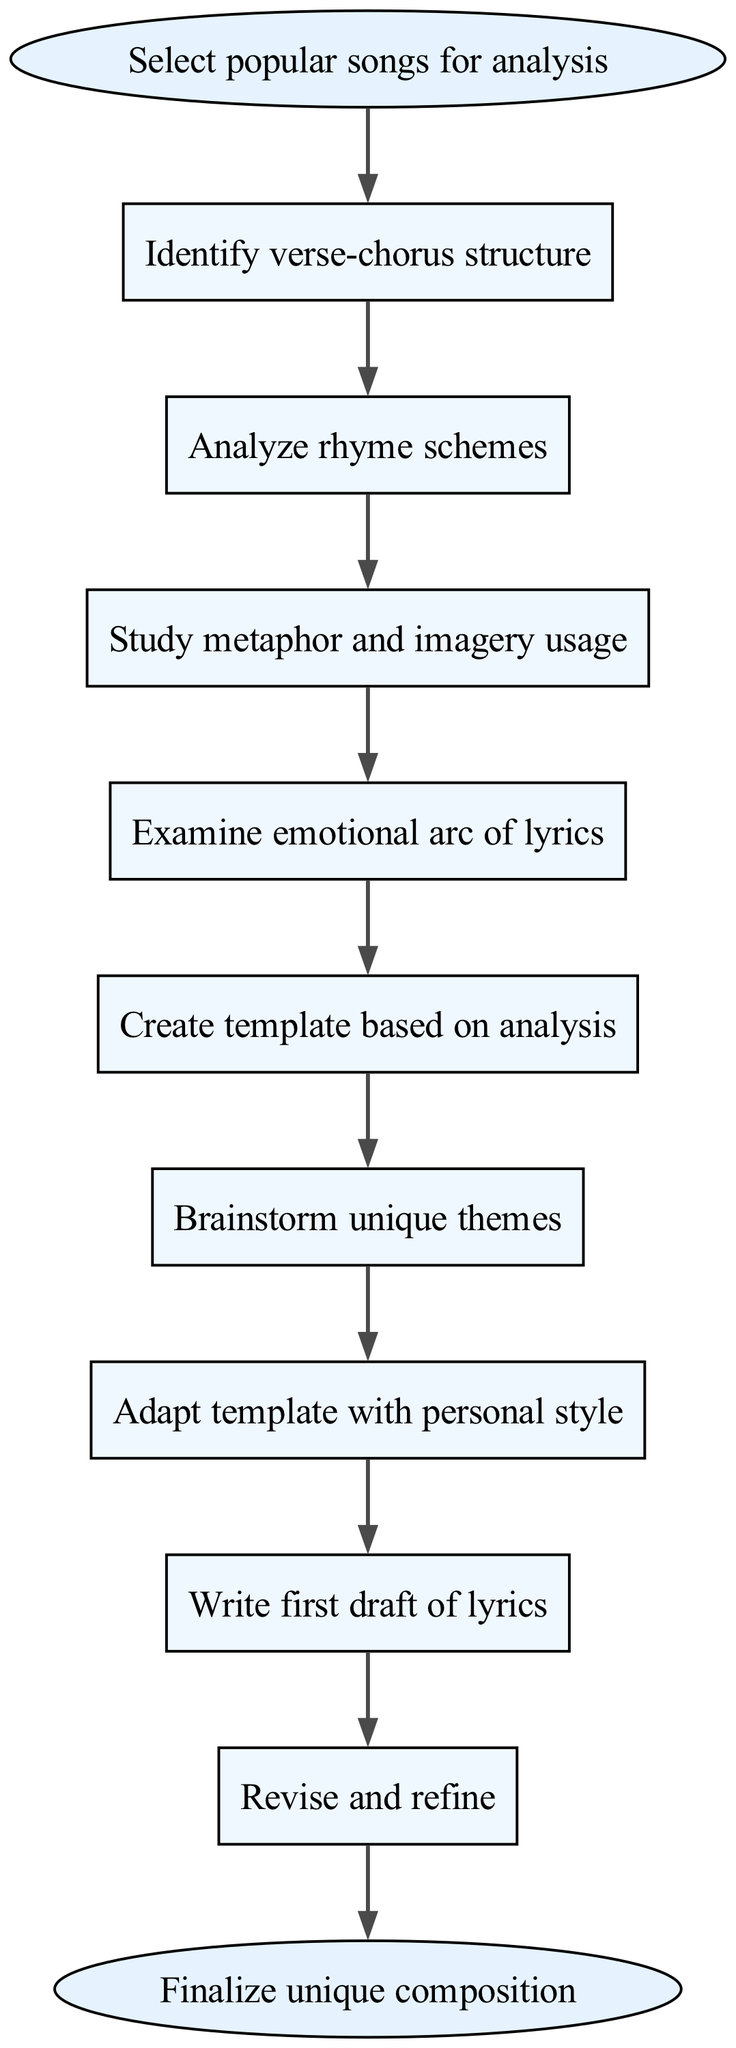What is the first step in the diagram? The first step in the diagram is represented by the node "Select popular songs for analysis." This initiates the process of analyzing successful song structures.
Answer: Select popular songs for analysis How many elements are included in the diagram? The diagram contains 9 elements before reaching the end. These elements are the steps that comprise the process outlined.
Answer: 9 What is the last step in the process? The last step in the process is indicated by the end node, which is "Finalize unique composition." This signifies the completion of the methodology.
Answer: Finalize unique composition What comes after analyzing rhyme schemes? After analyzing rhyme schemes, the next step is to "Study metaphor and imagery usage." This step builds upon the previous analysis of song structures.
Answer: Study metaphor and imagery usage How do you adapt the template according to the diagram? According to the diagram, after creating a template based on the analysis, you "Adapt template with personal style," indicating a personalization of the initial template.
Answer: Adapt template with personal style What type of structure do you identify first in the song analysis? The type of structure to be identified first in the analysis is the "verse-chorus structure." This element is crucial in breaking down how the song is constructed.
Answer: verse-chorus structure What is the relationship between "Create template based on analysis" and "Brainstorm unique themes"? The relationship is sequential; after "Create template based on analysis," the next step is "Brainstorm unique themes," indicating that once the template is established, future themes can be explored and generated.
Answer: Sequential relationship What is the transition from writing the first draft of lyrics? The transition from writing the first draft of lyrics is to "Revise and refine," which indicates that after the initial creation of lyrics, the next focus is on improving and polishing them.
Answer: Revise and refine 